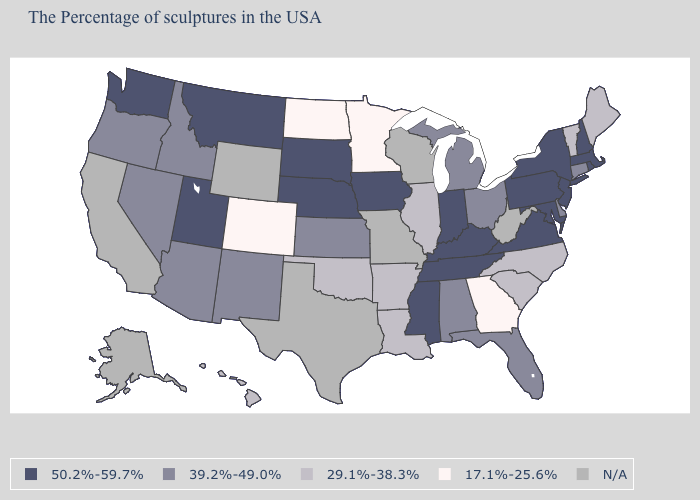What is the highest value in states that border North Dakota?
Write a very short answer. 50.2%-59.7%. Which states have the lowest value in the West?
Keep it brief. Colorado. What is the value of Colorado?
Short answer required. 17.1%-25.6%. What is the value of Alabama?
Write a very short answer. 39.2%-49.0%. How many symbols are there in the legend?
Write a very short answer. 5. Among the states that border Mississippi , does Tennessee have the highest value?
Concise answer only. Yes. Does the first symbol in the legend represent the smallest category?
Short answer required. No. Name the states that have a value in the range 29.1%-38.3%?
Write a very short answer. Maine, Vermont, North Carolina, South Carolina, Illinois, Louisiana, Arkansas, Oklahoma, Hawaii. Among the states that border Alabama , which have the highest value?
Be succinct. Tennessee, Mississippi. What is the value of Wyoming?
Write a very short answer. N/A. What is the highest value in the Northeast ?
Concise answer only. 50.2%-59.7%. What is the value of New York?
Answer briefly. 50.2%-59.7%. 